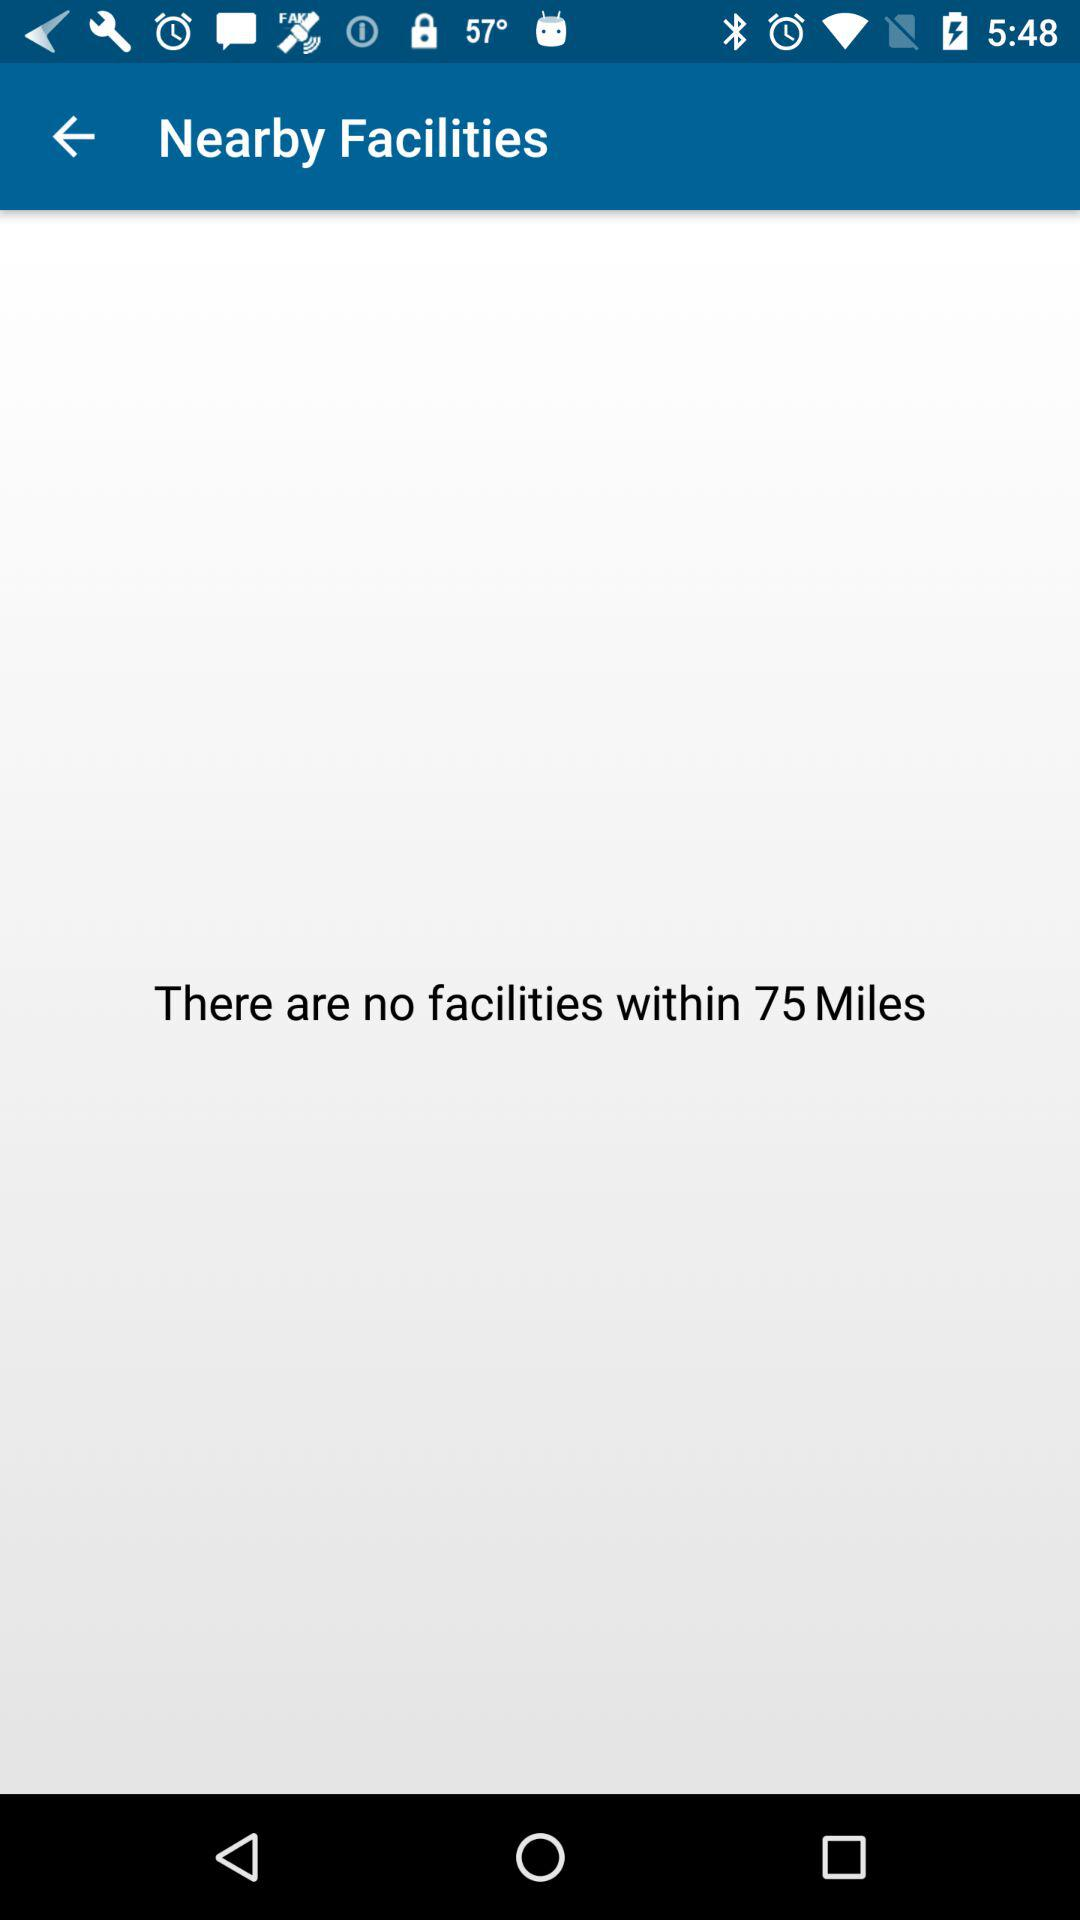There are no facilities within how many miles? There are no facilities within 75 miles. 